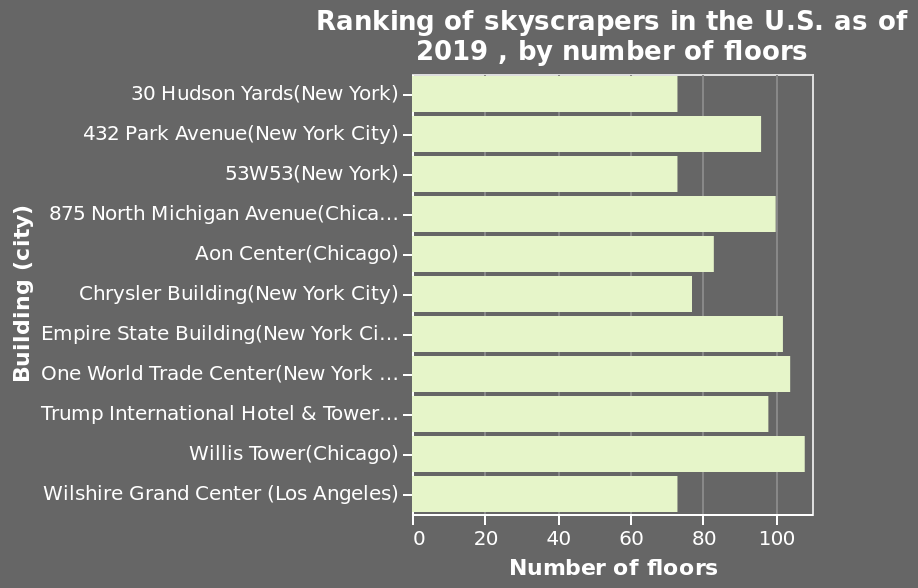<image>
What is the range of the x-axis in the bar diagram? The x-axis has a range from a minimum of 0 floors to a maximum of 100 floors. What was the tallest skyscraper in the USA in 2019?  The Willis Tower in Chicago. What does the y-axis represent in the bar diagram?  The y-axis represents the name of the cities where the skyscrapers are located. 